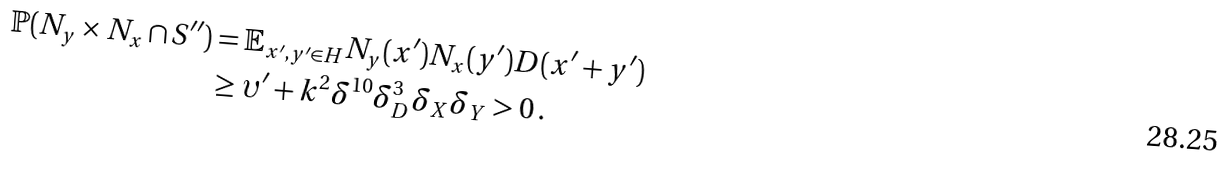Convert formula to latex. <formula><loc_0><loc_0><loc_500><loc_500>\mathbb { P } ( N _ { y } \times N _ { x } \cap S ^ { \prime \prime } ) & = \mathbb { E } _ { x ^ { \prime } , y ^ { \prime } \in H } N _ { y } ( x ^ { \prime } ) N _ { x } ( y ^ { \prime } ) D ( x ^ { \prime } + y ^ { \prime } ) \\ & \geq \upsilon ^ { \prime } + k ^ { 2 } \delta ^ { 1 0 } \delta _ { D } ^ { 3 } \delta _ { X } \delta _ { Y } > 0 \, .</formula> 